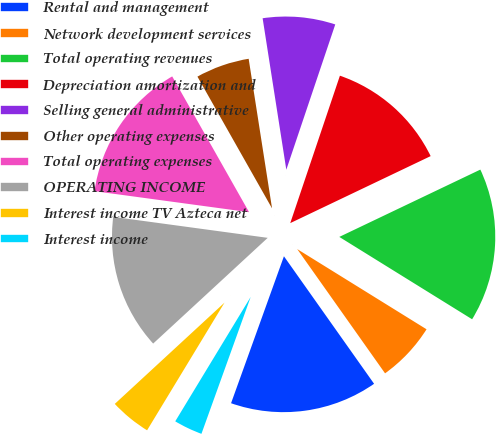Convert chart. <chart><loc_0><loc_0><loc_500><loc_500><pie_chart><fcel>Rental and management<fcel>Network development services<fcel>Total operating revenues<fcel>Depreciation amortization and<fcel>Selling general administrative<fcel>Other operating expenses<fcel>Total operating expenses<fcel>OPERATING INCOME<fcel>Interest income TV Azteca net<fcel>Interest income<nl><fcel>15.29%<fcel>6.37%<fcel>15.92%<fcel>12.74%<fcel>7.64%<fcel>5.73%<fcel>14.65%<fcel>14.01%<fcel>4.46%<fcel>3.18%<nl></chart> 